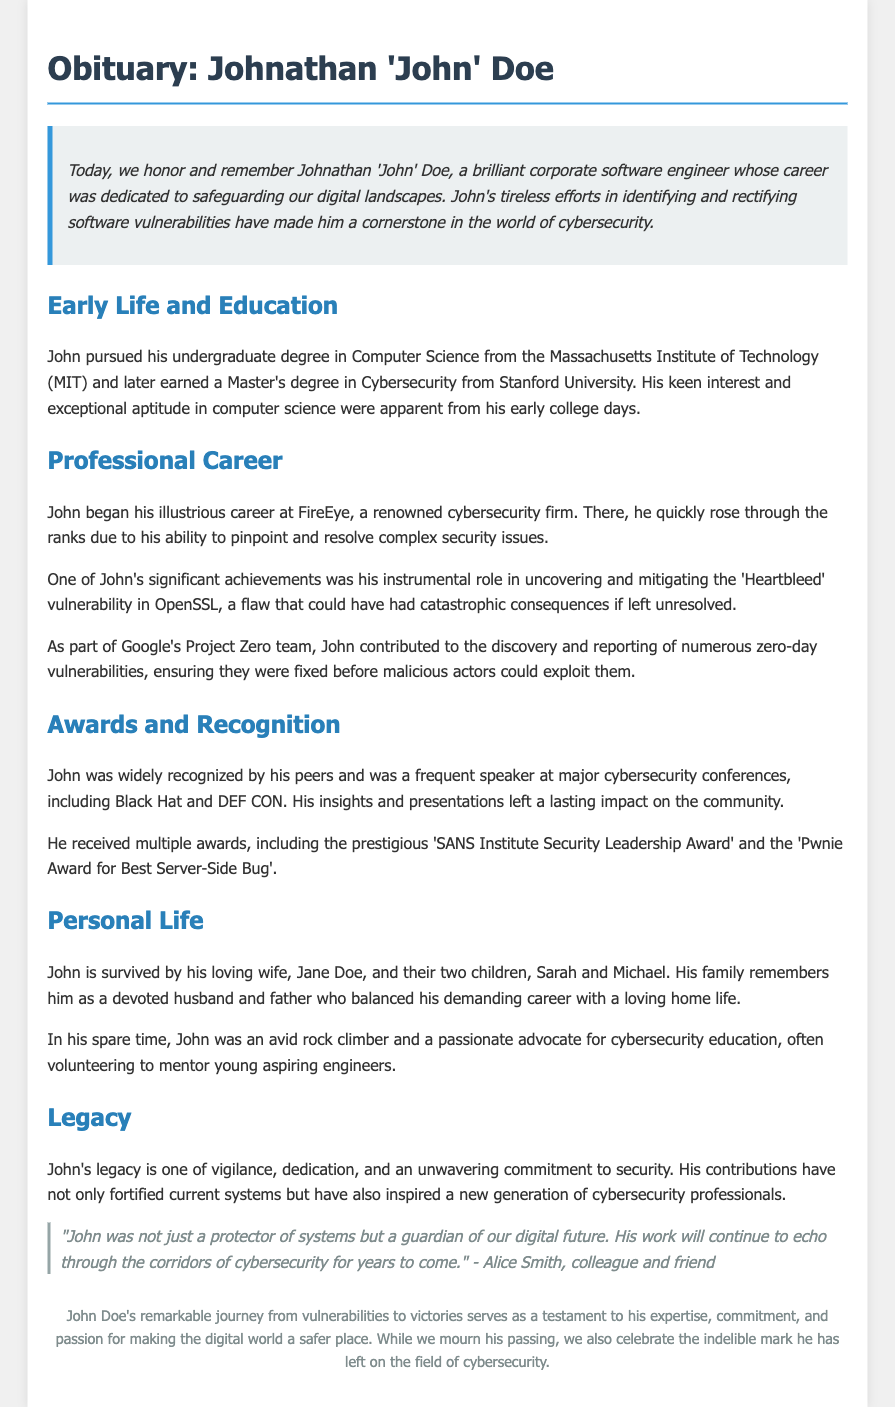What was John's undergraduate degree? The document states that John pursued his undergraduate degree in Computer Science from the Massachusetts Institute of Technology (MIT).
Answer: Computer Science Which company did John start his career with? The obituary mentions that John began his career at FireEye, a renowned cybersecurity firm.
Answer: FireEye What significant vulnerability did John mitigate? One of John's significant achievements was his role in uncovering and mitigating the 'Heartbleed' vulnerability in OpenSSL.
Answer: Heartbleed How many children did John have? The document notes that John is survived by two children, Sarah and Michael.
Answer: Two Which award did John receive for security leadership? The obituary lists the 'SANS Institute Security Leadership Award' as one of the awards he received.
Answer: SANS Institute Security Leadership Award What was John’s role in Google’s Project Zero? The document mentions that John contributed to the discovery and reporting of numerous zero-day vulnerabilities as part of Google's Project Zero team.
Answer: Discovery and reporting of vulnerabilities Who described John as a guardian of our digital future? The quote in the document attributes this description to Alice Smith, a colleague and friend of John.
Answer: Alice Smith What hobby did John enjoy in his spare time? The document indicates that John was an avid rock climber in his spare time.
Answer: Rock climbing What did John's contributions inspire? The obituary states that John's contributions inspire a new generation of cybersecurity professionals.
Answer: A new generation of cybersecurity professionals 